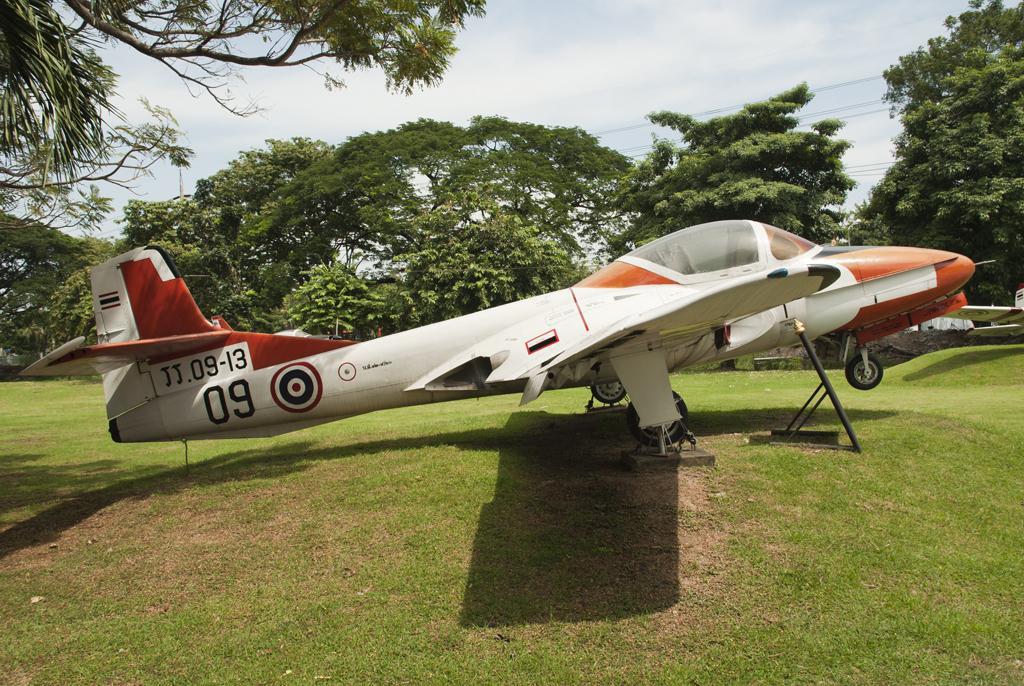How would you summarize this image in a sentence or two? In this picture we can see an aircraft and an object on the path. Behind the aircraft, there are trees, cables and the sky and a pole. 